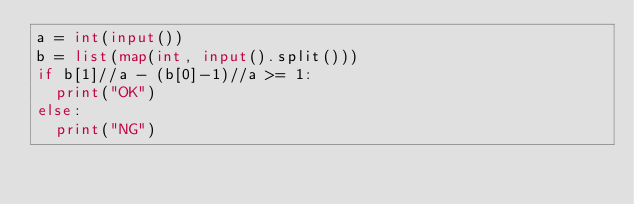Convert code to text. <code><loc_0><loc_0><loc_500><loc_500><_Python_>a = int(input())
b = list(map(int, input().split()))
if b[1]//a - (b[0]-1)//a >= 1:
  print("OK")
else:
  print("NG")
     
     </code> 